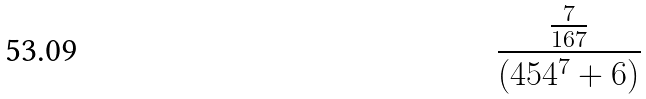<formula> <loc_0><loc_0><loc_500><loc_500>\frac { \frac { 7 } { 1 6 7 } } { ( 4 5 4 ^ { 7 } + 6 ) }</formula> 